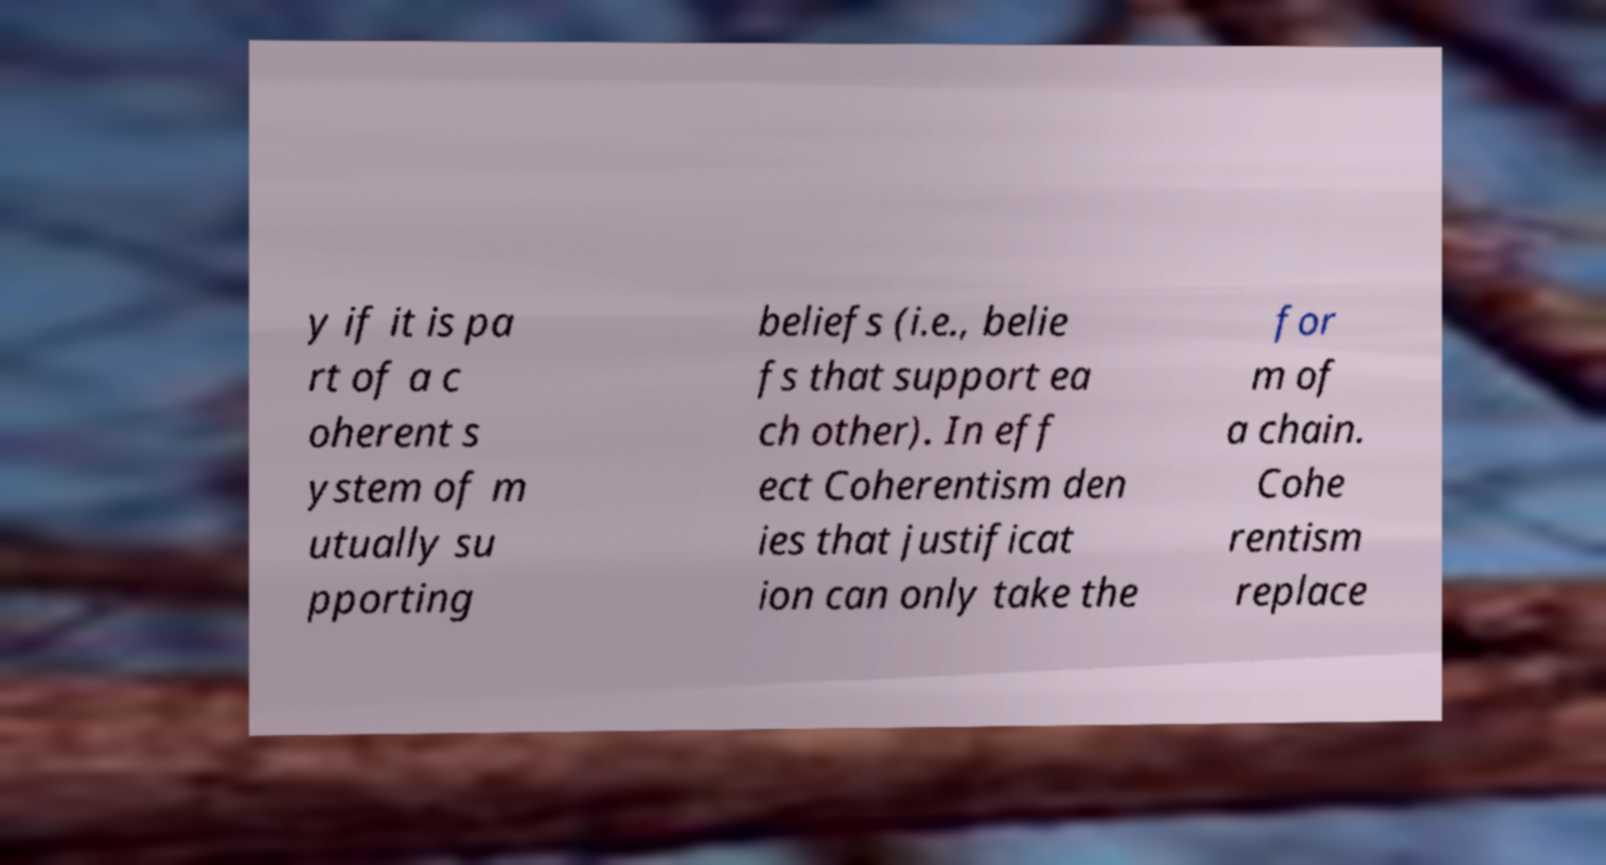For documentation purposes, I need the text within this image transcribed. Could you provide that? y if it is pa rt of a c oherent s ystem of m utually su pporting beliefs (i.e., belie fs that support ea ch other). In eff ect Coherentism den ies that justificat ion can only take the for m of a chain. Cohe rentism replace 